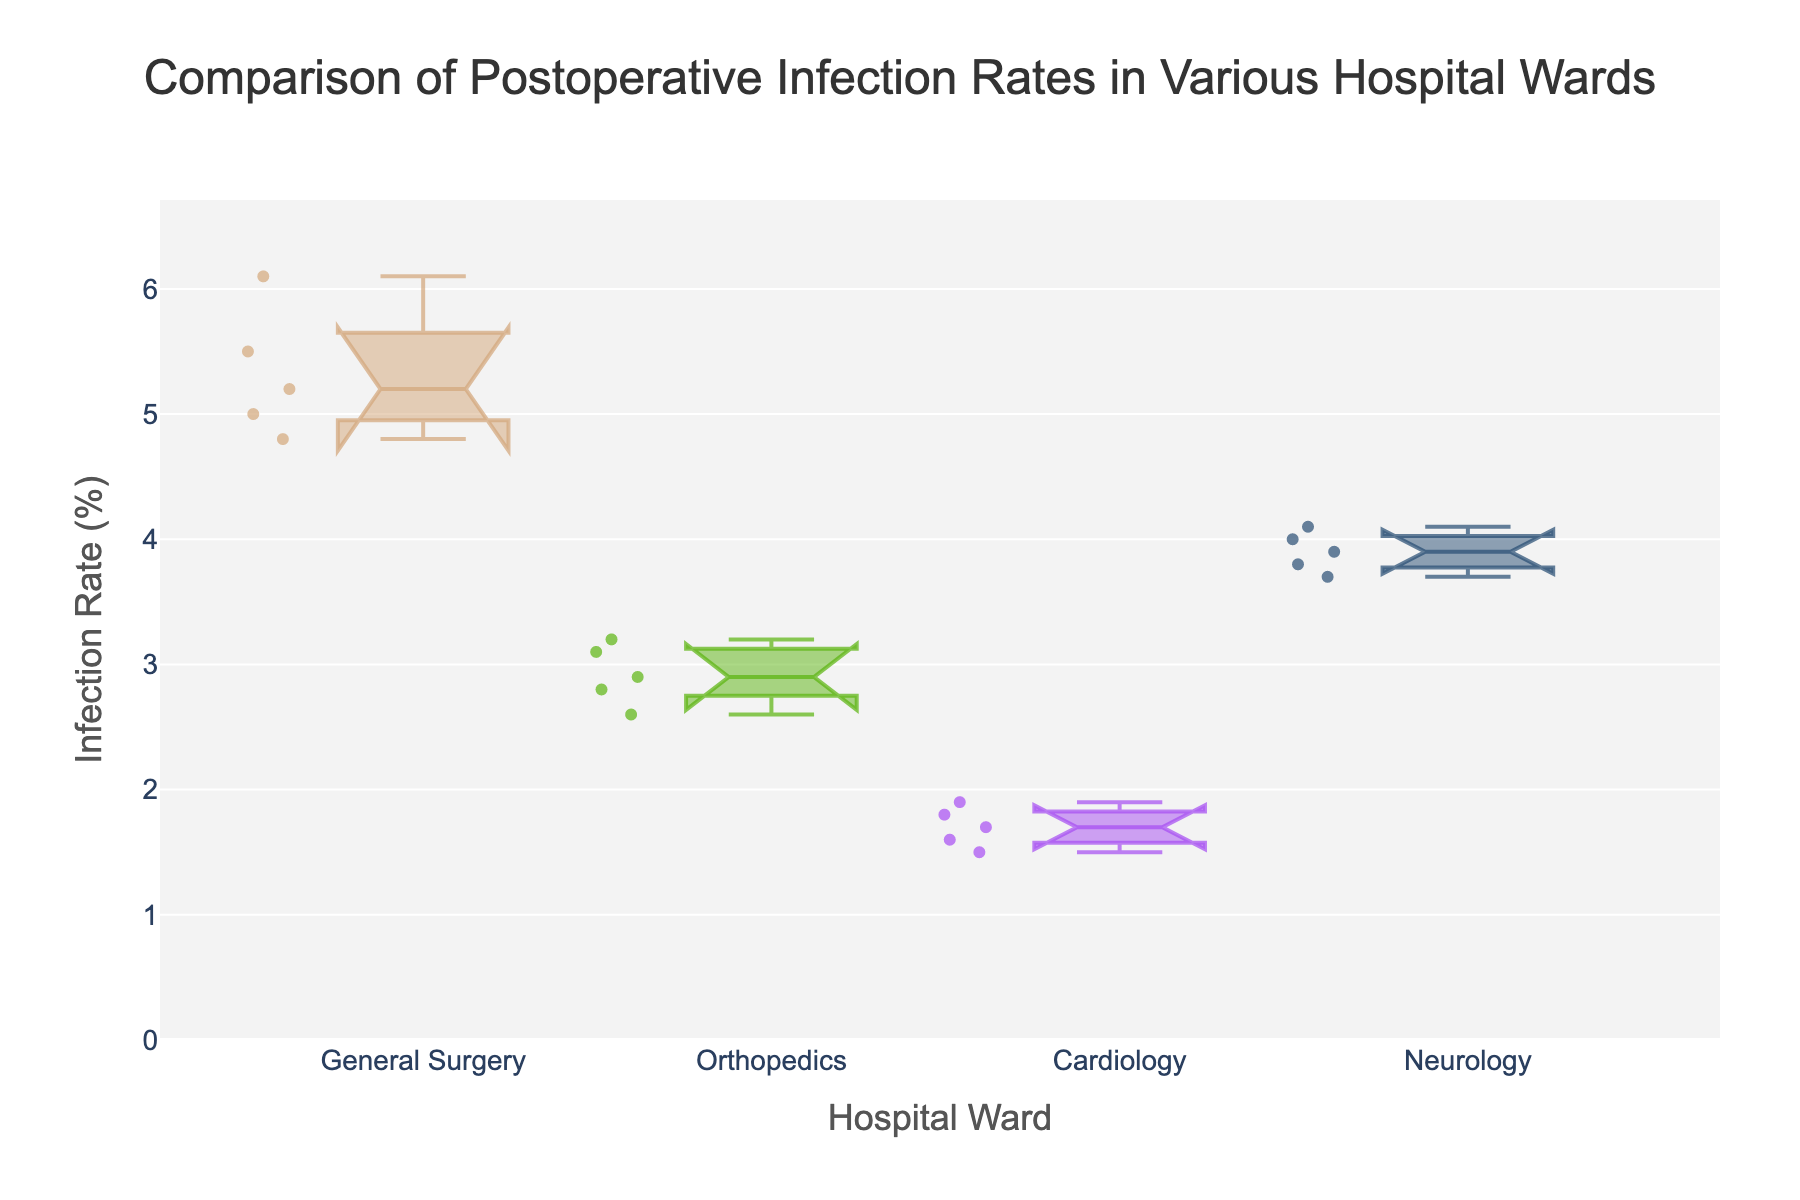What is the median infection rate for the General Surgery ward? The median is the middle value when the data points are ordered from lowest to highest. For General Surgery (4.8, 5.0, 5.2, 5.5, 6.1), the median value is 5.2.
Answer: 5.2 Which ward has the highest median infection rate? By comparing the medians for each ward, you can identify which one is the highest. General Surgery has the highest median (5.2), followed by Neurology (3.9), Orthopedics (2.9), and Cardiology (1.7).
Answer: General Surgery Which ward has the smallest interquartile range (IQR) for infection rates? The IQR is the difference between the first quartile (Q1) and the third quartile (Q3). By visually inspecting the boxplot notches, determine the smallest spread. The smallest IQR appears to be in the Cardiology ward.
Answer: Cardiology How does the infection rate variability of Orthopedics compare to Neurology? Variability can be assessed by comparing the spread of data points and the range of notches in the box plots for both wards. Neurology shows a wider spread and larger notches than Orthopedics, indicating higher variability.
Answer: Orthopedics has less variability than Neurology Is there significant overlap in the notches between the General Surgery and Orthopedics wards? Notches represent the confidence interval around the median. If the notches do not overlap, there is a statistical difference. The notches for General Surgery and Orthopedics do overlap, indicating no significant difference.
Answer: Yes What is the median infection rate for the Cardiology ward? The median is the middle value when the data points are ordered from lowest to highest. For Cardiology (1.5, 1.6, 1.7, 1.8, 1.9), the median value is 1.7.
Answer: 1.7 Compare the upper quartiles of the Neurology and Cardiology wards. Which is higher? The upper quartile (Q3) is the value below which 75% of the data fall. The Neurology box plot's upper edge is higher than that of the Cardiology box plot.
Answer: Neurology Which ward has the lowest maximum recorded infection rate? The maximum infection rate is the highest data point in each ward’s distribution. Cardiology has the lowest maximum recorded infection rate (~1.9%).
Answer: Cardiology Are there any outliers in the General Surgery ward infection rates data? Outliers are data points that fall significantly outside the range defined by the box and whiskers. For General Surgery, no points clearly fall outside this range in the box plot.
Answer: No What is the average infection rate of the Orthopedics ward? Summing the infection rates (2.6, 3.1, 2.8, 3.2, 2.9) gives 14.6. Dividing by the number of data points (5) results in an average infection rate of 2.92.
Answer: 2.92 